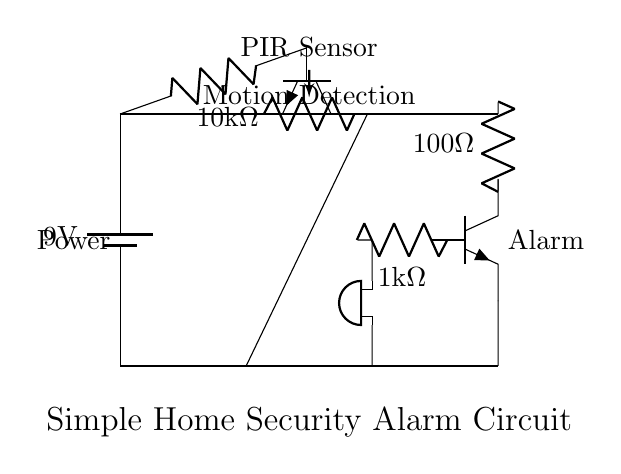What is the voltage of the power supply in this circuit? The voltage is specified as 9 volts, which is indicated next to the battery symbol in the circuit diagram.
Answer: 9 volts What type of sensor is used in this circuit? The circuit includes a PIR sensor, which is noted in the labels next to the relevant component in the diagram.
Answer: PIR sensor What is the resistance value of the resistor connected to the motion sensor? The resistance value is noted as 10 kilo-ohms next to the resistor connected to the base of the transistor from the PIR sensor.
Answer: 10 kilo-ohms How many transistors are present in this alarm circuit? The circuit includes two transistors, which are labeled in the diagram for clarity.
Answer: 2 Why is there a resistor connected to the buzzer? The 100 ohm resistor is likely used to limit the current flowing through the buzzer to prevent damage, which is essential for protecting the components in a circuit.
Answer: To limit current What is the purpose of the second transistor in this circuit? The second transistor acts as a switch that amplifies the current from the motion sensor through the base, allowing the alarm (buzzer) to sound when motion is detected.
Answer: Amplifies current What happens when the PIR sensor detects motion? When motion is detected, the PIR sensor allows current to flow, activating the first transistor, which subsequently triggers the second transistor to sound the buzzer.
Answer: Activates the alarm 